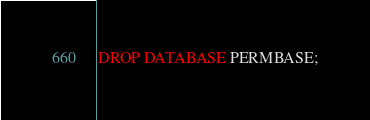Convert code to text. <code><loc_0><loc_0><loc_500><loc_500><_SQL_>DROP DATABASE PERMBASE;</code> 